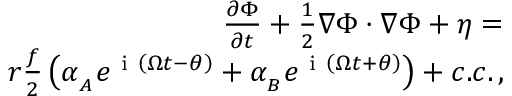<formula> <loc_0><loc_0><loc_500><loc_500>\begin{array} { r } { \frac { \partial \Phi } { \partial t } + \frac { 1 } { 2 } \nabla \Phi \cdot \nabla \Phi + \eta = } \\ { r \frac { f } { 2 } \left ( \alpha _ { _ { A } } e ^ { i \left ( \Omega t - \theta \right ) } + \alpha _ { _ { B } } e ^ { i \left ( \Omega t + \theta \right ) } \right ) + c . c . \, , } \end{array}</formula> 